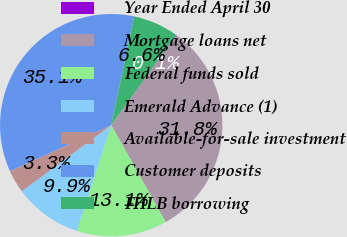<chart> <loc_0><loc_0><loc_500><loc_500><pie_chart><fcel>Year Ended April 30<fcel>Mortgage loans net<fcel>Federal funds sold<fcel>Emerald Advance (1)<fcel>Available-for-sale investment<fcel>Customer deposits<fcel>FHLB borrowing<nl><fcel>0.08%<fcel>31.84%<fcel>13.14%<fcel>9.88%<fcel>3.34%<fcel>35.11%<fcel>6.61%<nl></chart> 